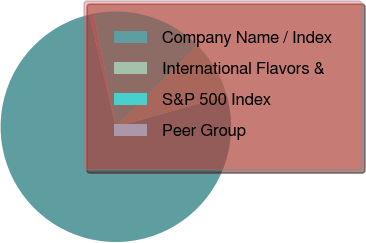Convert chart. <chart><loc_0><loc_0><loc_500><loc_500><pie_chart><fcel>Company Name / Index<fcel>International Flavors &<fcel>S&P 500 Index<fcel>Peer Group<nl><fcel>75.65%<fcel>8.12%<fcel>15.62%<fcel>0.61%<nl></chart> 